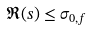Convert formula to latex. <formula><loc_0><loc_0><loc_500><loc_500>\Re ( s ) \leq \sigma _ { 0 , f }</formula> 